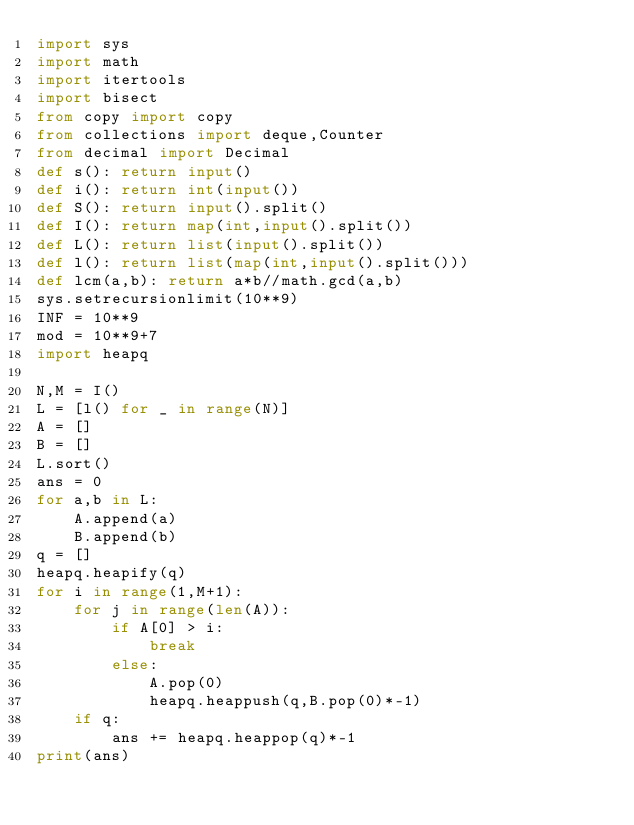Convert code to text. <code><loc_0><loc_0><loc_500><loc_500><_Python_>import sys
import math
import itertools
import bisect
from copy import copy
from collections import deque,Counter
from decimal import Decimal
def s(): return input()
def i(): return int(input())
def S(): return input().split()
def I(): return map(int,input().split())
def L(): return list(input().split())
def l(): return list(map(int,input().split()))
def lcm(a,b): return a*b//math.gcd(a,b)
sys.setrecursionlimit(10**9)
INF = 10**9
mod = 10**9+7
import heapq

N,M = I()
L = [l() for _ in range(N)]
A = []
B = []
L.sort()
ans = 0
for a,b in L:
    A.append(a)
    B.append(b)
q = []
heapq.heapify(q)
for i in range(1,M+1):
    for j in range(len(A)):
        if A[0] > i:
            break
        else:
            A.pop(0)
            heapq.heappush(q,B.pop(0)*-1)
    if q:
        ans += heapq.heappop(q)*-1
print(ans)</code> 